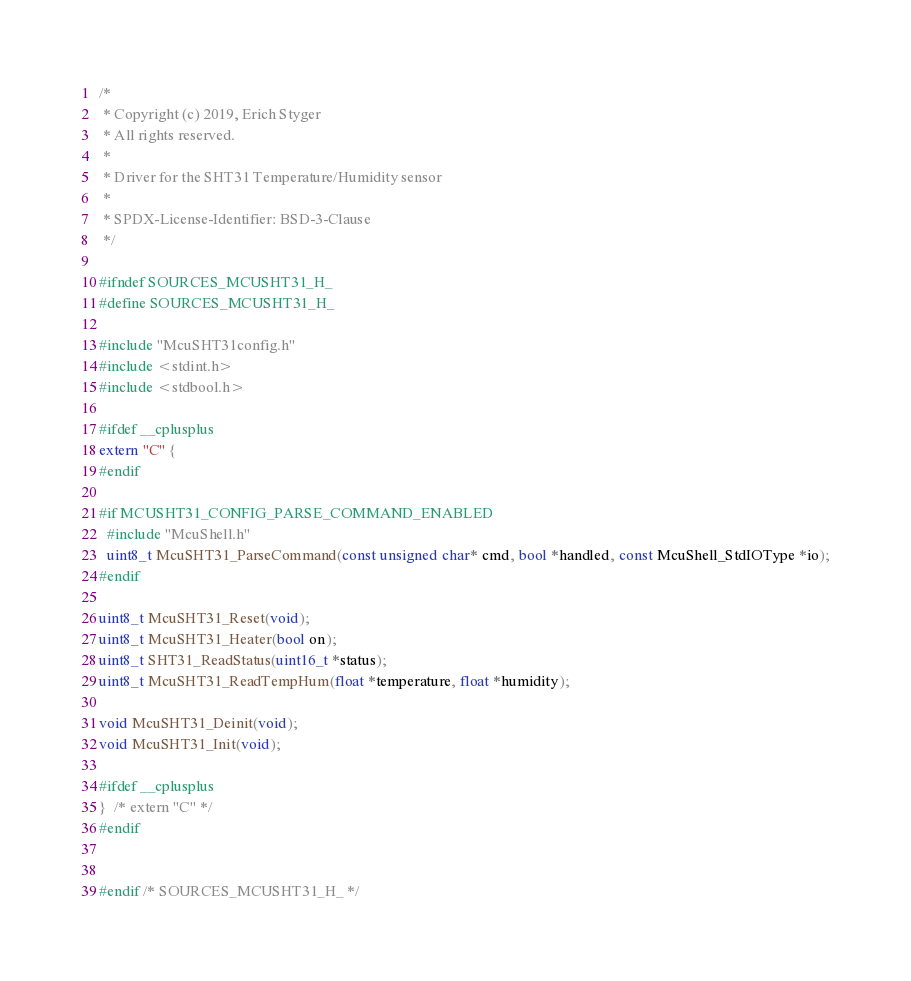<code> <loc_0><loc_0><loc_500><loc_500><_C_>/*
 * Copyright (c) 2019, Erich Styger
 * All rights reserved.
 *
 * Driver for the SHT31 Temperature/Humidity sensor
 *
 * SPDX-License-Identifier: BSD-3-Clause
 */

#ifndef SOURCES_MCUSHT31_H_
#define SOURCES_MCUSHT31_H_

#include "McuSHT31config.h"
#include <stdint.h>
#include <stdbool.h>

#ifdef __cplusplus
extern "C" {
#endif

#if MCUSHT31_CONFIG_PARSE_COMMAND_ENABLED
  #include "McuShell.h"
  uint8_t McuSHT31_ParseCommand(const unsigned char* cmd, bool *handled, const McuShell_StdIOType *io);
#endif

uint8_t McuSHT31_Reset(void);
uint8_t McuSHT31_Heater(bool on);
uint8_t SHT31_ReadStatus(uint16_t *status);
uint8_t McuSHT31_ReadTempHum(float *temperature, float *humidity);

void McuSHT31_Deinit(void);
void McuSHT31_Init(void);

#ifdef __cplusplus
}  /* extern "C" */
#endif


#endif /* SOURCES_MCUSHT31_H_ */
</code> 